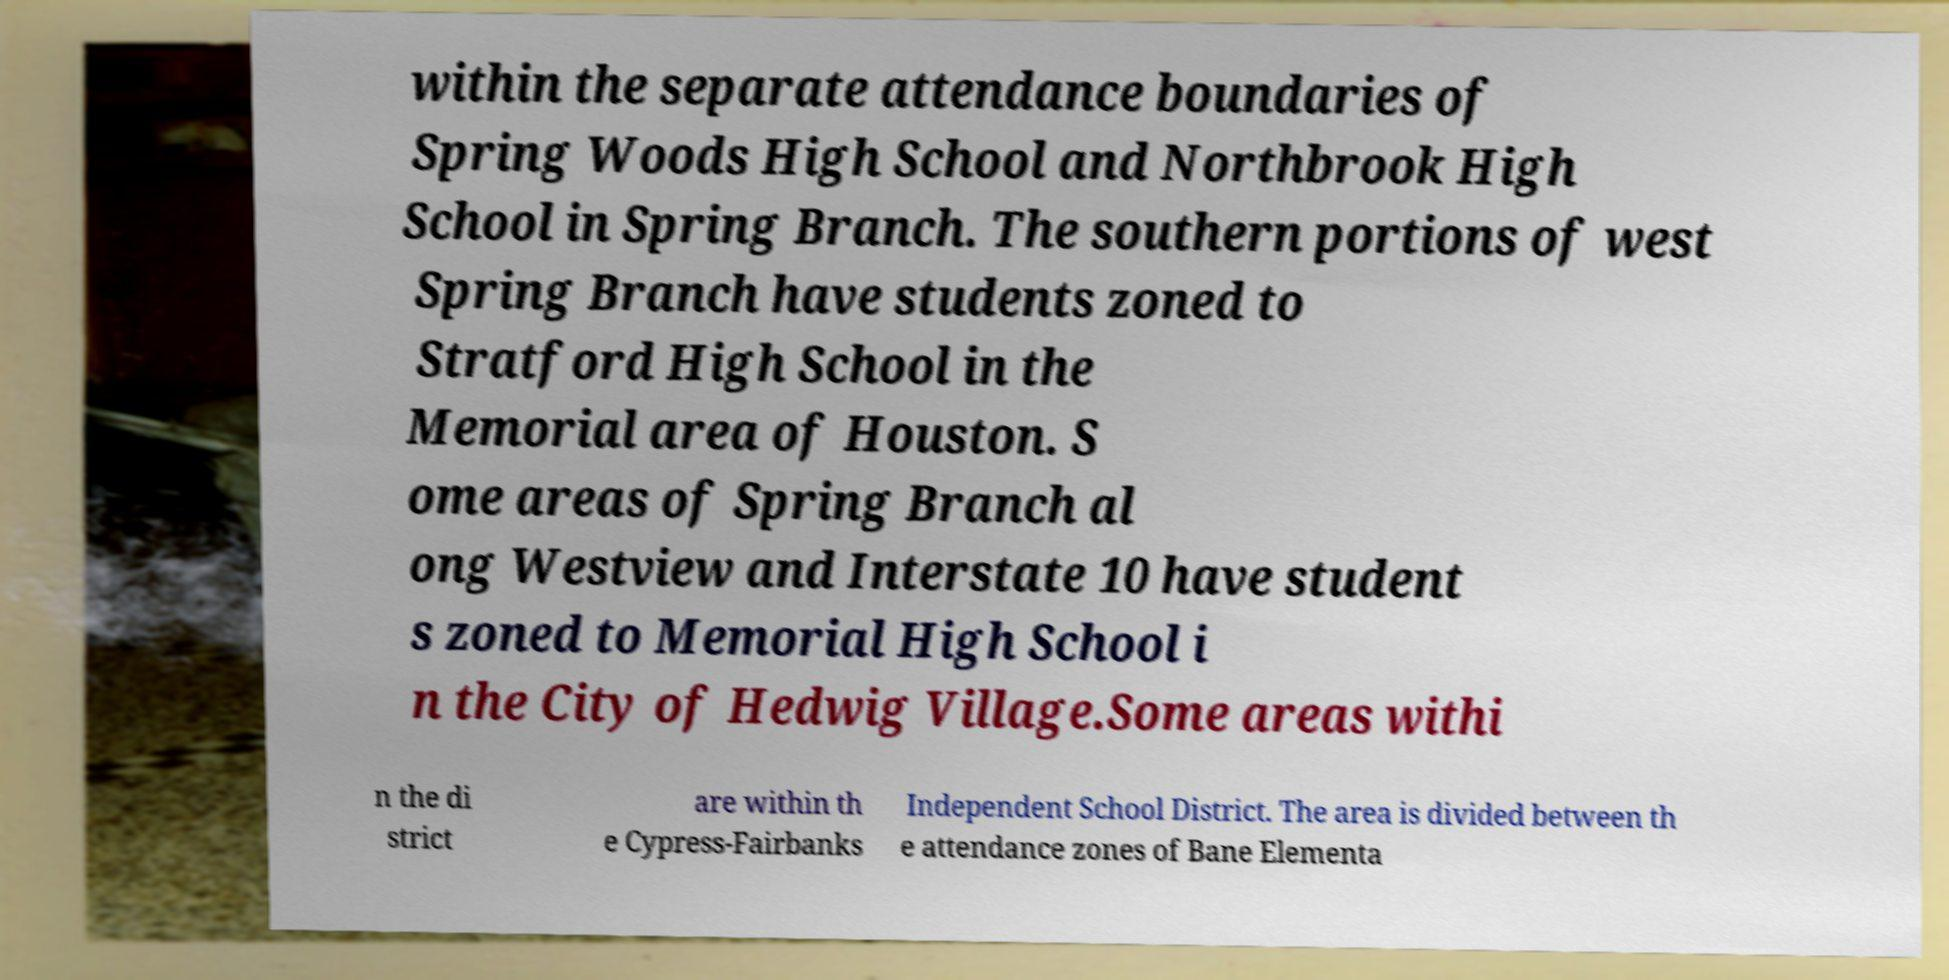What messages or text are displayed in this image? I need them in a readable, typed format. within the separate attendance boundaries of Spring Woods High School and Northbrook High School in Spring Branch. The southern portions of west Spring Branch have students zoned to Stratford High School in the Memorial area of Houston. S ome areas of Spring Branch al ong Westview and Interstate 10 have student s zoned to Memorial High School i n the City of Hedwig Village.Some areas withi n the di strict are within th e Cypress-Fairbanks Independent School District. The area is divided between th e attendance zones of Bane Elementa 